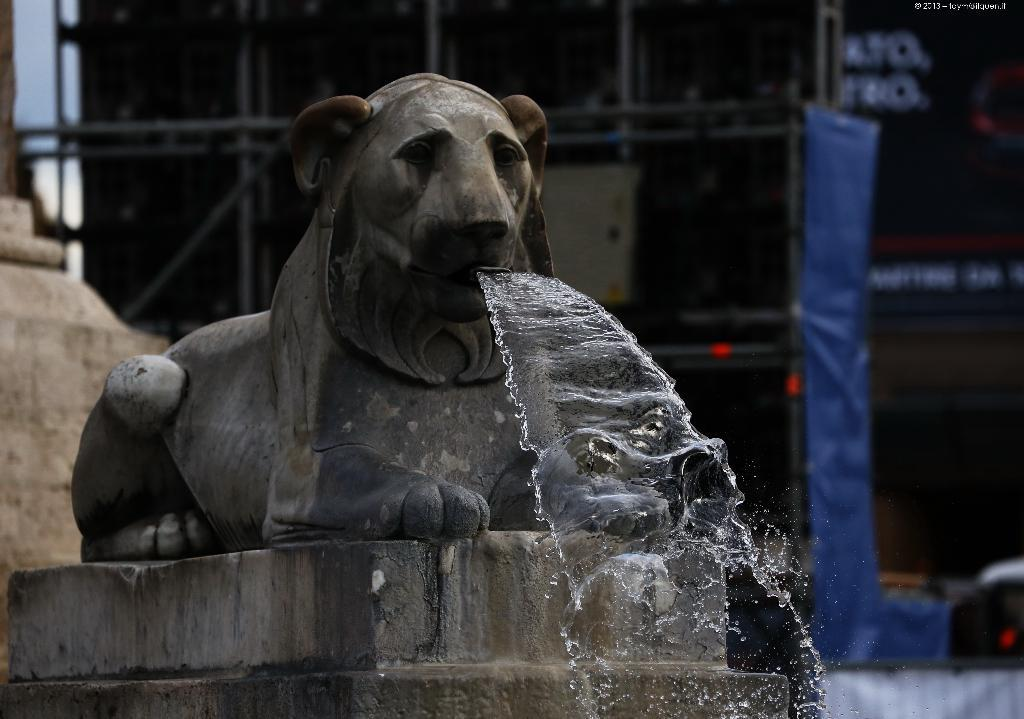What is the main subject in the image? There is a statue in the image. What natural feature can be seen in the image? There is a waterfall in the image. What objects are present in the image that might be used for support or structure? There are poles in the image. What type of material is present in the image? There is a cloth in the image. What type of information is conveyed in the image? There is a board with text in the image. What type of payment is accepted at the wax museum in the image? There is no wax museum or payment mentioned in the image; it features a statue, waterfall, poles, cloth, and a board with text. Does the existence of the statue in the image prove the existence of a mythical creature? The image does not provide enough information to determine the existence of a mythical creature; it only shows a statue. 